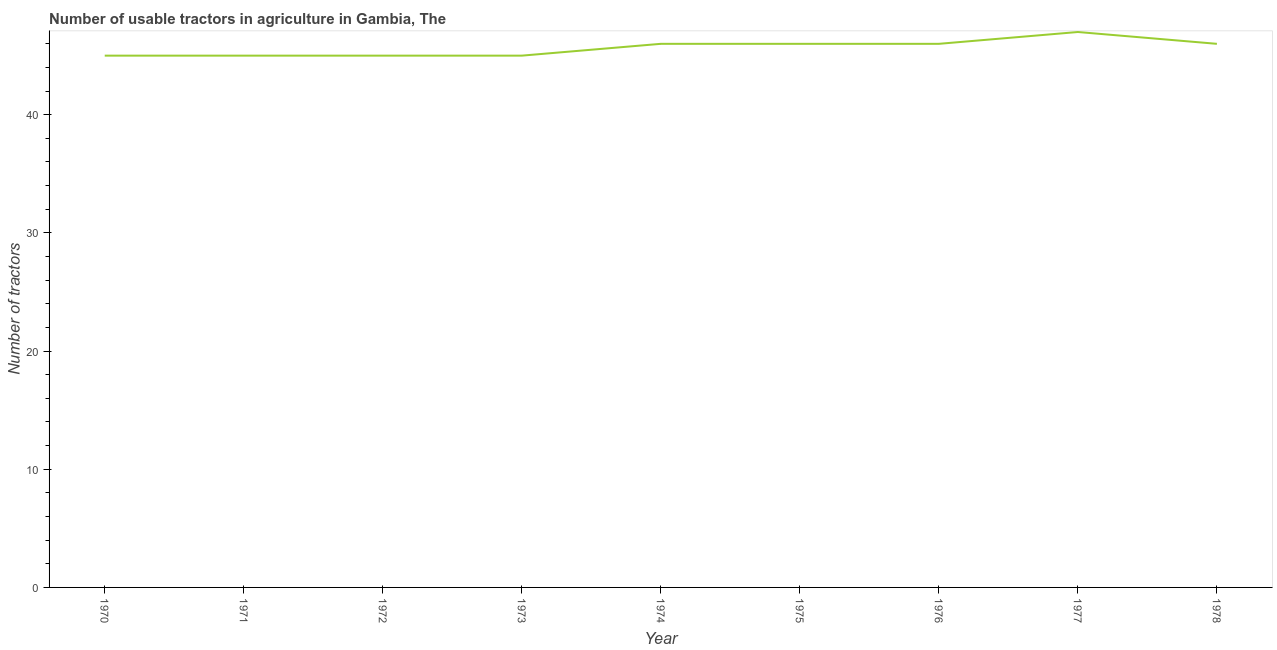What is the number of tractors in 1970?
Provide a short and direct response. 45. Across all years, what is the maximum number of tractors?
Your answer should be very brief. 47. Across all years, what is the minimum number of tractors?
Give a very brief answer. 45. In which year was the number of tractors maximum?
Ensure brevity in your answer.  1977. What is the sum of the number of tractors?
Give a very brief answer. 411. What is the difference between the number of tractors in 1971 and 1974?
Your answer should be compact. -1. What is the average number of tractors per year?
Your response must be concise. 45.67. Do a majority of the years between 1977 and 1978 (inclusive) have number of tractors greater than 36 ?
Provide a succinct answer. Yes. What is the ratio of the number of tractors in 1972 to that in 1974?
Offer a terse response. 0.98. Is the number of tractors in 1971 less than that in 1978?
Offer a terse response. Yes. Is the difference between the number of tractors in 1970 and 1976 greater than the difference between any two years?
Your answer should be compact. No. What is the difference between the highest and the lowest number of tractors?
Make the answer very short. 2. How many lines are there?
Your response must be concise. 1. What is the difference between two consecutive major ticks on the Y-axis?
Provide a short and direct response. 10. Are the values on the major ticks of Y-axis written in scientific E-notation?
Offer a terse response. No. Does the graph contain any zero values?
Your answer should be compact. No. What is the title of the graph?
Your answer should be very brief. Number of usable tractors in agriculture in Gambia, The. What is the label or title of the X-axis?
Your answer should be compact. Year. What is the label or title of the Y-axis?
Keep it short and to the point. Number of tractors. What is the Number of tractors in 1970?
Give a very brief answer. 45. What is the Number of tractors of 1971?
Offer a very short reply. 45. What is the Number of tractors of 1972?
Make the answer very short. 45. What is the Number of tractors in 1974?
Ensure brevity in your answer.  46. What is the Number of tractors in 1975?
Provide a short and direct response. 46. What is the difference between the Number of tractors in 1970 and 1974?
Make the answer very short. -1. What is the difference between the Number of tractors in 1970 and 1975?
Offer a terse response. -1. What is the difference between the Number of tractors in 1970 and 1976?
Your answer should be compact. -1. What is the difference between the Number of tractors in 1970 and 1977?
Keep it short and to the point. -2. What is the difference between the Number of tractors in 1971 and 1973?
Give a very brief answer. 0. What is the difference between the Number of tractors in 1971 and 1974?
Offer a very short reply. -1. What is the difference between the Number of tractors in 1972 and 1974?
Provide a succinct answer. -1. What is the difference between the Number of tractors in 1972 and 1975?
Give a very brief answer. -1. What is the difference between the Number of tractors in 1972 and 1976?
Offer a terse response. -1. What is the difference between the Number of tractors in 1972 and 1978?
Give a very brief answer. -1. What is the difference between the Number of tractors in 1973 and 1975?
Give a very brief answer. -1. What is the difference between the Number of tractors in 1973 and 1976?
Provide a succinct answer. -1. What is the difference between the Number of tractors in 1973 and 1978?
Your answer should be very brief. -1. What is the difference between the Number of tractors in 1974 and 1976?
Offer a terse response. 0. What is the difference between the Number of tractors in 1974 and 1978?
Make the answer very short. 0. What is the difference between the Number of tractors in 1975 and 1976?
Your answer should be very brief. 0. What is the difference between the Number of tractors in 1975 and 1978?
Offer a terse response. 0. What is the difference between the Number of tractors in 1976 and 1977?
Ensure brevity in your answer.  -1. What is the ratio of the Number of tractors in 1970 to that in 1971?
Give a very brief answer. 1. What is the ratio of the Number of tractors in 1970 to that in 1972?
Your response must be concise. 1. What is the ratio of the Number of tractors in 1970 to that in 1977?
Give a very brief answer. 0.96. What is the ratio of the Number of tractors in 1971 to that in 1972?
Provide a short and direct response. 1. What is the ratio of the Number of tractors in 1971 to that in 1973?
Your answer should be compact. 1. What is the ratio of the Number of tractors in 1971 to that in 1974?
Offer a terse response. 0.98. What is the ratio of the Number of tractors in 1971 to that in 1975?
Keep it short and to the point. 0.98. What is the ratio of the Number of tractors in 1971 to that in 1978?
Your answer should be very brief. 0.98. What is the ratio of the Number of tractors in 1972 to that in 1973?
Offer a very short reply. 1. What is the ratio of the Number of tractors in 1972 to that in 1974?
Provide a succinct answer. 0.98. What is the ratio of the Number of tractors in 1972 to that in 1975?
Make the answer very short. 0.98. What is the ratio of the Number of tractors in 1972 to that in 1978?
Your response must be concise. 0.98. What is the ratio of the Number of tractors in 1973 to that in 1974?
Give a very brief answer. 0.98. What is the ratio of the Number of tractors in 1973 to that in 1976?
Offer a terse response. 0.98. What is the ratio of the Number of tractors in 1973 to that in 1978?
Your response must be concise. 0.98. What is the ratio of the Number of tractors in 1974 to that in 1975?
Provide a succinct answer. 1. What is the ratio of the Number of tractors in 1974 to that in 1977?
Your answer should be compact. 0.98. What is the ratio of the Number of tractors in 1974 to that in 1978?
Keep it short and to the point. 1. What is the ratio of the Number of tractors in 1975 to that in 1976?
Give a very brief answer. 1. What is the ratio of the Number of tractors in 1975 to that in 1978?
Offer a terse response. 1. What is the ratio of the Number of tractors in 1976 to that in 1977?
Offer a terse response. 0.98. What is the ratio of the Number of tractors in 1977 to that in 1978?
Offer a terse response. 1.02. 